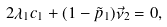<formula> <loc_0><loc_0><loc_500><loc_500>2 \lambda _ { 1 } c _ { 1 } + ( 1 - \tilde { p } _ { 1 } ) \vec { \nu } _ { 2 } = 0 ,</formula> 